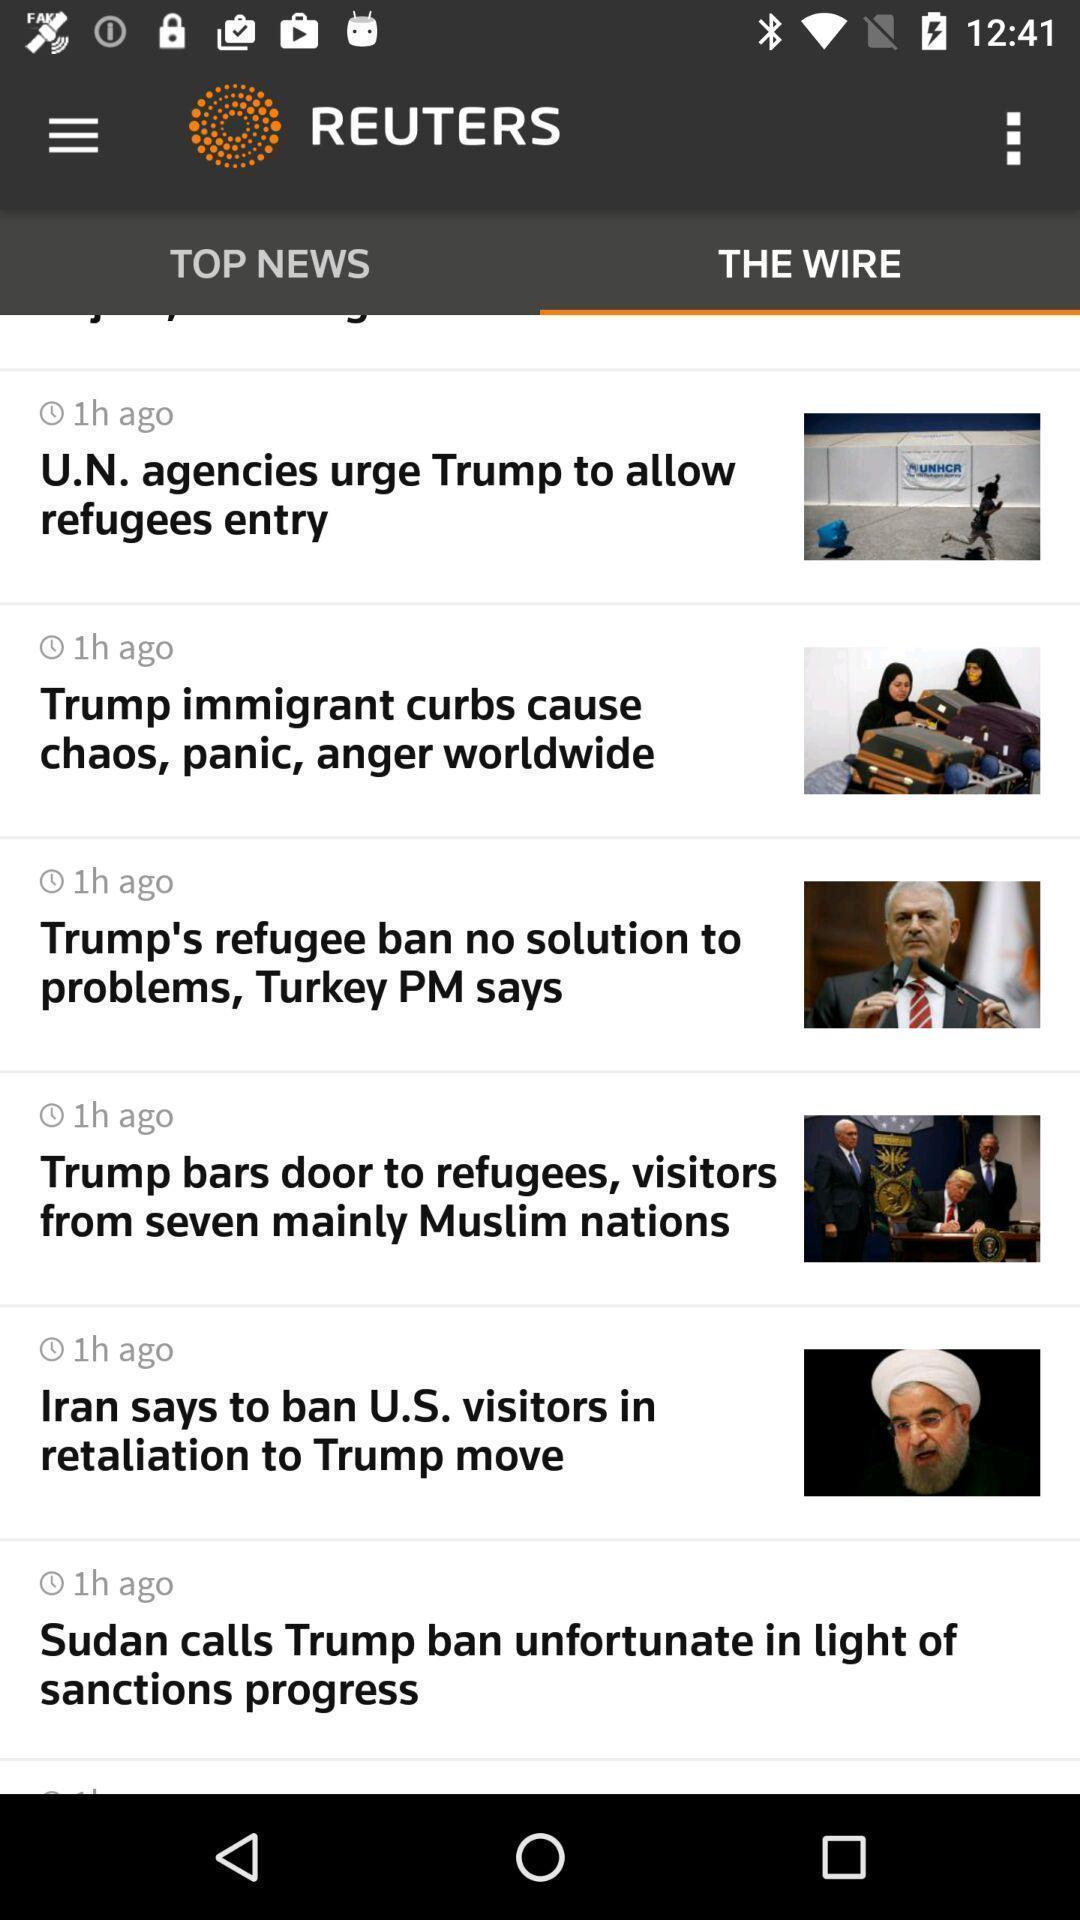Provide a detailed account of this screenshot. Page displaying the news in a news app. 